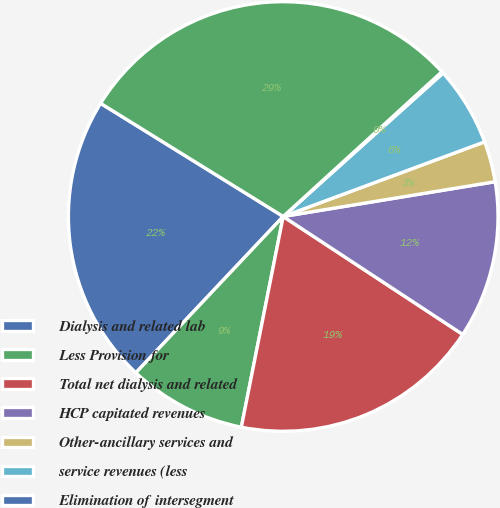Convert chart to OTSL. <chart><loc_0><loc_0><loc_500><loc_500><pie_chart><fcel>Dialysis and related lab<fcel>Less Provision for<fcel>Total net dialysis and related<fcel>HCP capitated revenues<fcel>Other-ancillary services and<fcel>service revenues (less<fcel>Elimination of intersegment<fcel>Consolidated net revenues<nl><fcel>21.8%<fcel>8.91%<fcel>18.87%<fcel>11.84%<fcel>3.06%<fcel>5.99%<fcel>0.13%<fcel>29.4%<nl></chart> 